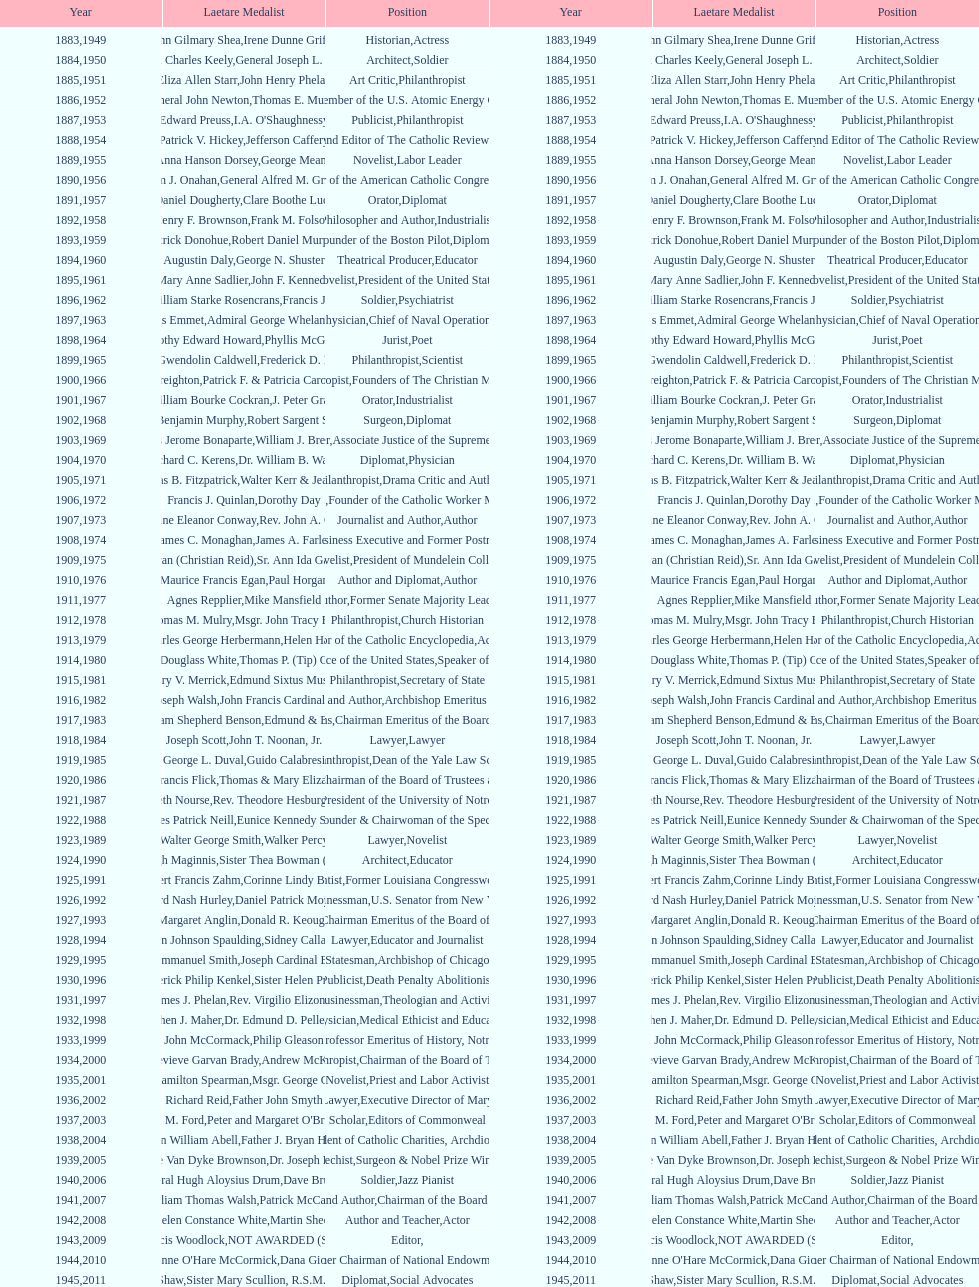How many times does philanthropist appear in the position column on this chart? 9. 